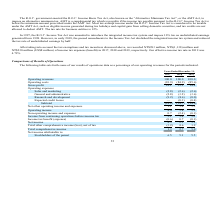According to United Micro Electronics's financial document, Why did the Operating revenues decreased from 2018 to 2019?  Based on the financial document, the answer is primarily due to decreased other operating revenues, decreased foundry wafer sale, and 2.5% depreciation of the NTD in 2019 from 2018.. Also, Why did the Operating costs decreased from 2018 to 2019? Based on the financial document, the answer is primarily due to the decreased depreciation expense and other operating costs, which was partially offset by the increased direct material costs.. Also, Why did the gross margin decreased from 2018 to 2019? Based on the financial document, the answer is primarily due to an annual decline of 2.9% in average selling price.. Also, can you calculate: What is the average of Gross profit? To answer this question, I need to perform calculations using the financial data. The calculation is: (18.1+15.1+14.4) / 3, which equals 15.87 (percentage). This is based on the information: "ting costs (81.9) (84.9) (85.6) Gross profit 18.1 15.1 14.4 Operating expenses Sales and marketing (2.8) (2.6) (2.6) General and administrative (2.8) (3.2 Operating costs (81.9) (84.9) (85.6) Gross pr..." The key data points involved are: 14.4, 15.1, 18.1. Also, can you calculate: What is the average Operating expenses? To answer this question, I need to perform calculations using the financial data. The calculation is: (14.8+14.7+14.6) / 3, which equals 14.7 (percentage). This is based on the information: "edit losses — (0.3) (0.4) Subtotal (14.8) (14.7) (14.6) Net other operating income and expenses 1.1 3.4 3.5 Operating income 4.4 3.8 3.3 Non-operating inc 0) Expected credit losses — (0.3) (0.4) Subto..." The key data points involved are: 14.6, 14.8. Also, can you calculate: What is the average Operating income? To answer this question, I need to perform calculations using the financial data. The calculation is: (4.4+3.8+3.3) / 3, which equals 3.83 (percentage). This is based on the information: "and expenses 1.1 3.4 3.5 Operating income 4.4 3.8 3.3 Non-operating income and expenses 0.7 (2.4) (0.1) Income from continuing operations before income t ome and expenses 1.1 3.4 3.5 Operating income ..." The key data points involved are: 3.3, 4.4. 